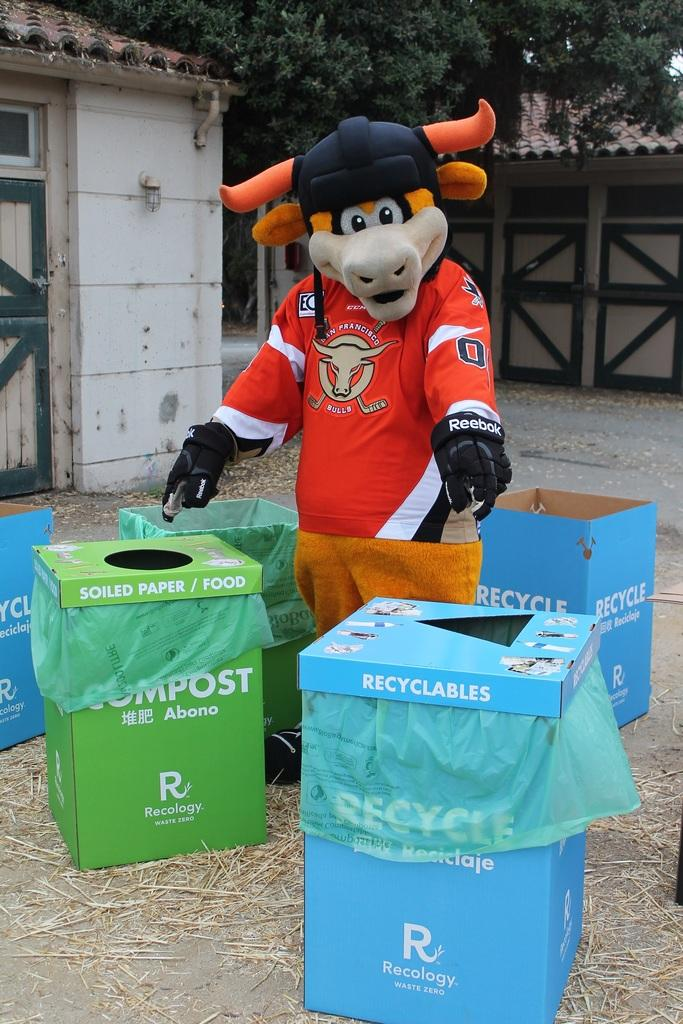<image>
Share a concise interpretation of the image provided. A mascot for the San Francisco Bulls standing in the middle of Recycle and Compost disposal bins pointing to them. 